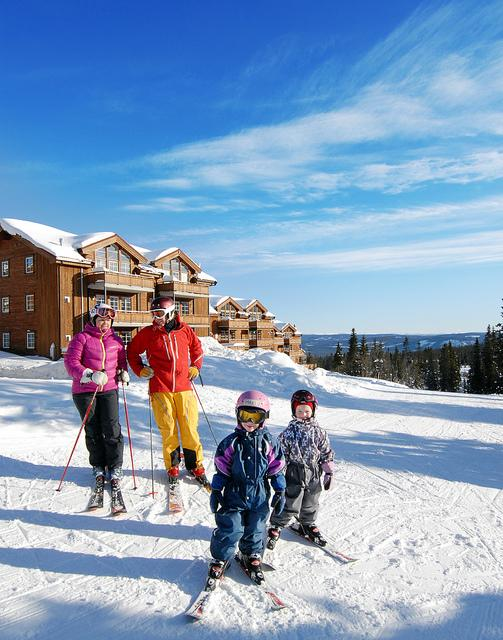Who are the adults standing behind the children?

Choices:
A) coaches
B) teachers
C) neighbors
D) parents parents 